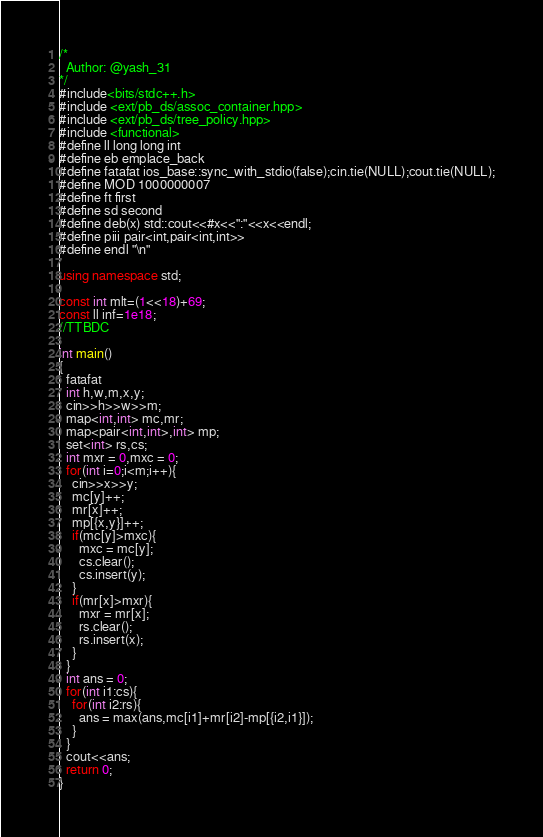<code> <loc_0><loc_0><loc_500><loc_500><_C++_>/*
  Author: @yash_31
*/
#include<bits/stdc++.h>
#include <ext/pb_ds/assoc_container.hpp>
#include <ext/pb_ds/tree_policy.hpp> 
#include <functional>
#define ll long long int
#define eb emplace_back
#define fatafat ios_base::sync_with_stdio(false);cin.tie(NULL);cout.tie(NULL);
#define MOD 1000000007
#define ft first
#define sd second
#define deb(x) std::cout<<#x<<":"<<x<<endl;
#define piii pair<int,pair<int,int>>
#define endl "\n"
 
using namespace std;

const int mlt=(1<<18)+69;
const ll inf=1e18;
//TTBDC

int main()
{
  fatafat
  int h,w,m,x,y;
  cin>>h>>w>>m;
  map<int,int> mc,mr;
  map<pair<int,int>,int> mp;
  set<int> rs,cs;
  int mxr = 0,mxc = 0;
  for(int i=0;i<m;i++){
    cin>>x>>y;
    mc[y]++;
    mr[x]++;
    mp[{x,y}]++;
    if(mc[y]>mxc){
      mxc = mc[y];
      cs.clear();
      cs.insert(y);
    }
    if(mr[x]>mxr){
      mxr = mr[x];
      rs.clear();
      rs.insert(x);
    }
  }
  int ans = 0;
  for(int i1:cs){
    for(int i2:rs){
      ans = max(ans,mc[i1]+mr[i2]-mp[{i2,i1}]);
    }
  }
  cout<<ans;
  return 0;
}</code> 